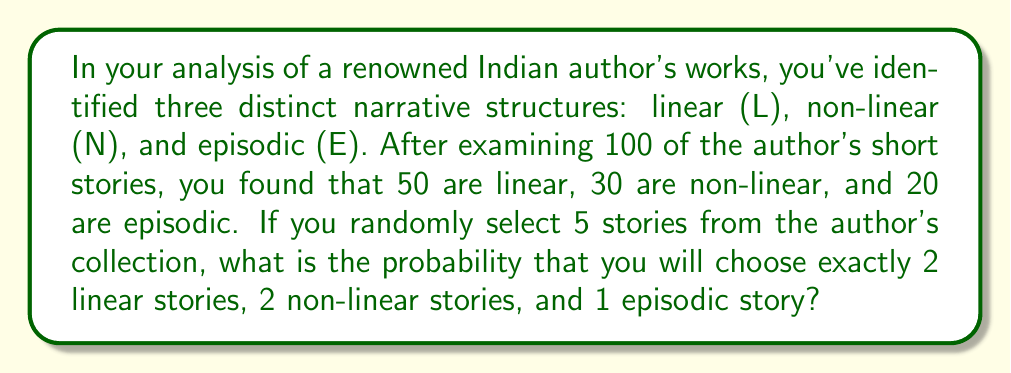Can you solve this math problem? To solve this problem, we'll use the multinomial distribution, which is an extension of the binomial distribution for more than two outcomes.

Step 1: Identify the parameters
- Total number of trials (stories selected): $n = 5$
- Probability of selecting a linear story: $p_L = \frac{50}{100} = 0.5$
- Probability of selecting a non-linear story: $p_N = \frac{30}{100} = 0.3$
- Probability of selecting an episodic story: $p_E = \frac{20}{100} = 0.2$
- Number of linear stories we want: $k_L = 2$
- Number of non-linear stories we want: $k_N = 2$
- Number of episodic stories we want: $k_E = 1$

Step 2: Apply the multinomial probability formula
The probability is given by:

$$P(X_L = k_L, X_N = k_N, X_E = k_E) = \frac{n!}{k_L! k_N! k_E!} p_L^{k_L} p_N^{k_N} p_E^{k_E}$$

Step 3: Substitute the values
$$P(X_L = 2, X_N = 2, X_E = 1) = \frac{5!}{2! 2! 1!} (0.5)^2 (0.3)^2 (0.2)^1$$

Step 4: Calculate
$$\begin{align*}
P(X_L = 2, X_N = 2, X_E = 1) &= \frac{5 \cdot 4 \cdot 3 \cdot 2 \cdot 1}{(2 \cdot 1)(2 \cdot 1)(1)} \cdot 0.25 \cdot 0.09 \cdot 0.2 \\
&= 60 \cdot 0.25 \cdot 0.09 \cdot 0.2 \\
&= 60 \cdot 0.0045 \\
&= 0.27
\end{align*}$$

Therefore, the probability of selecting exactly 2 linear stories, 2 non-linear stories, and 1 episodic story when randomly choosing 5 stories from the author's collection is 0.27 or 27%.
Answer: 0.27 